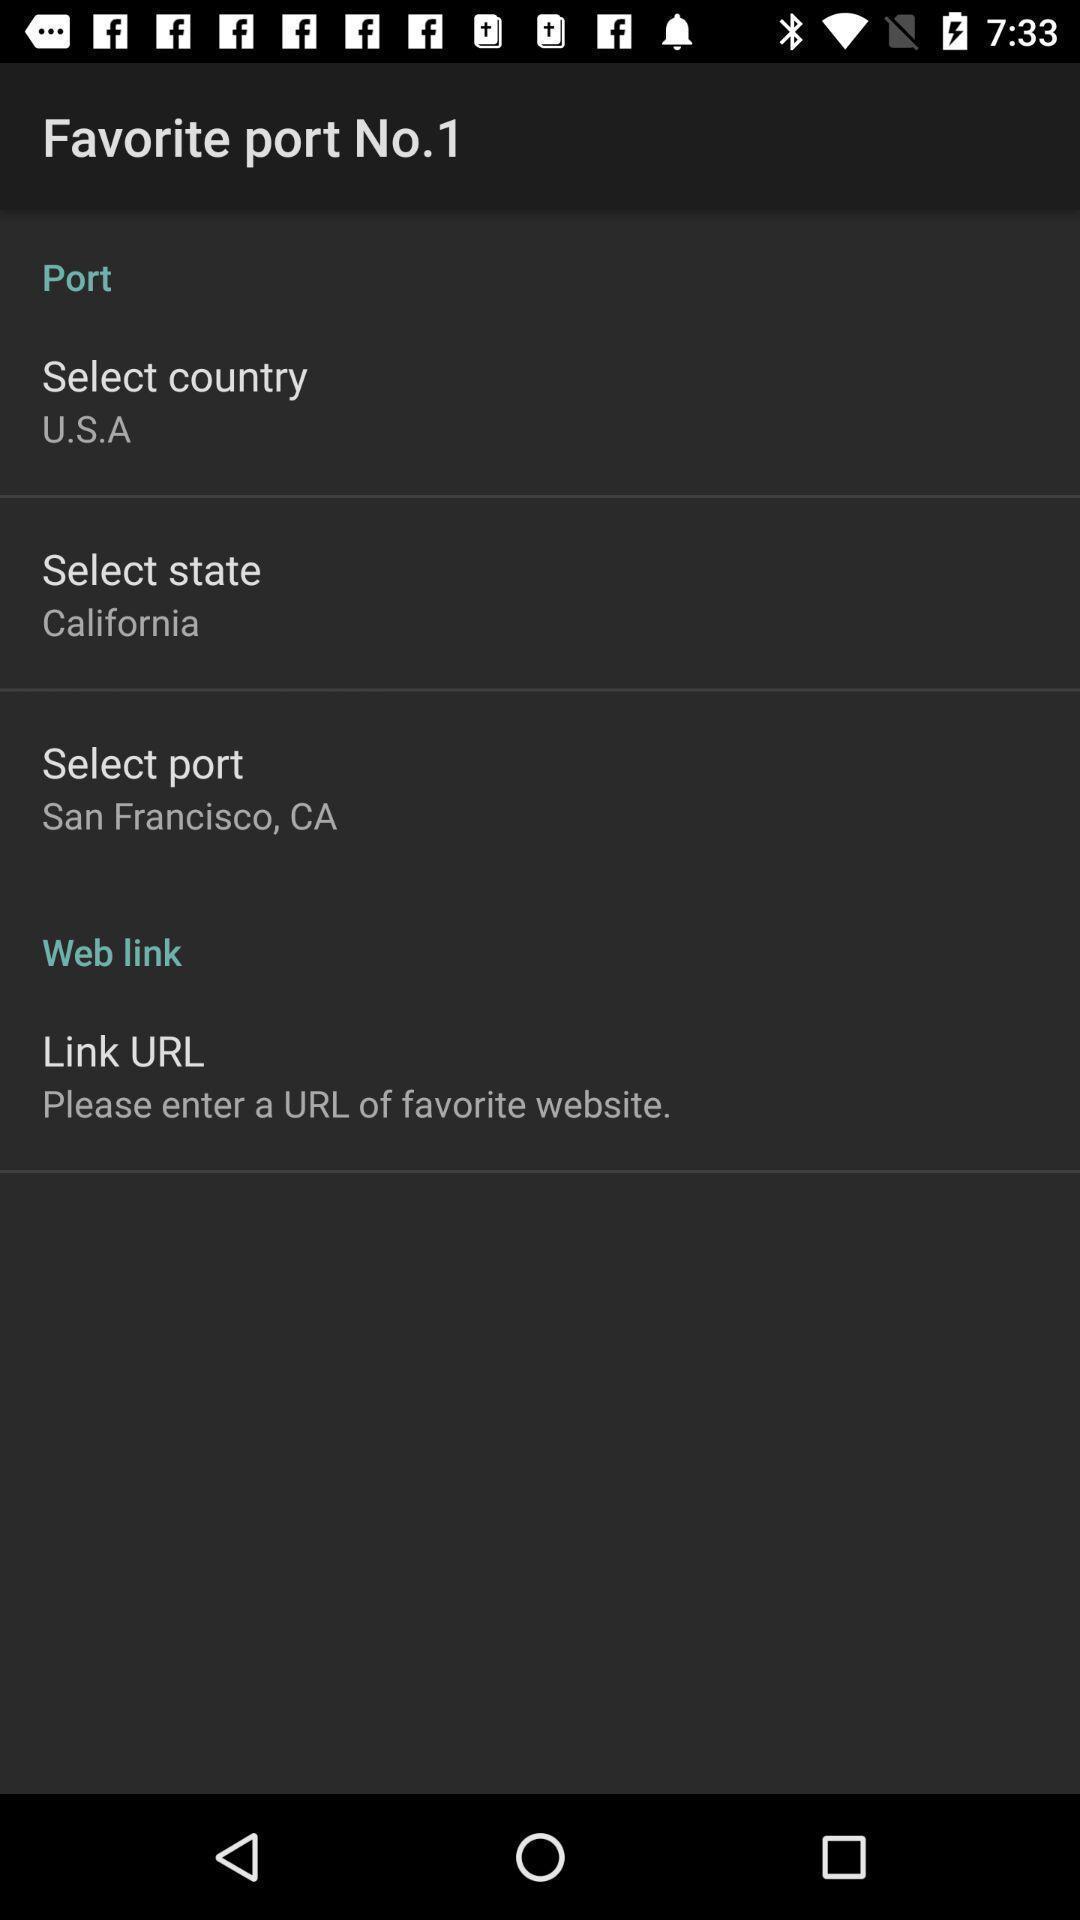Give me a summary of this screen capture. Page displaying location details. 